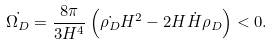Convert formula to latex. <formula><loc_0><loc_0><loc_500><loc_500>\dot { \Omega _ { D } } = \frac { 8 \pi } { 3 H ^ { 4 } } \left ( \dot { \rho _ { D } } H ^ { 2 } - 2 H \dot { H } \rho _ { D } \right ) < 0 .</formula> 